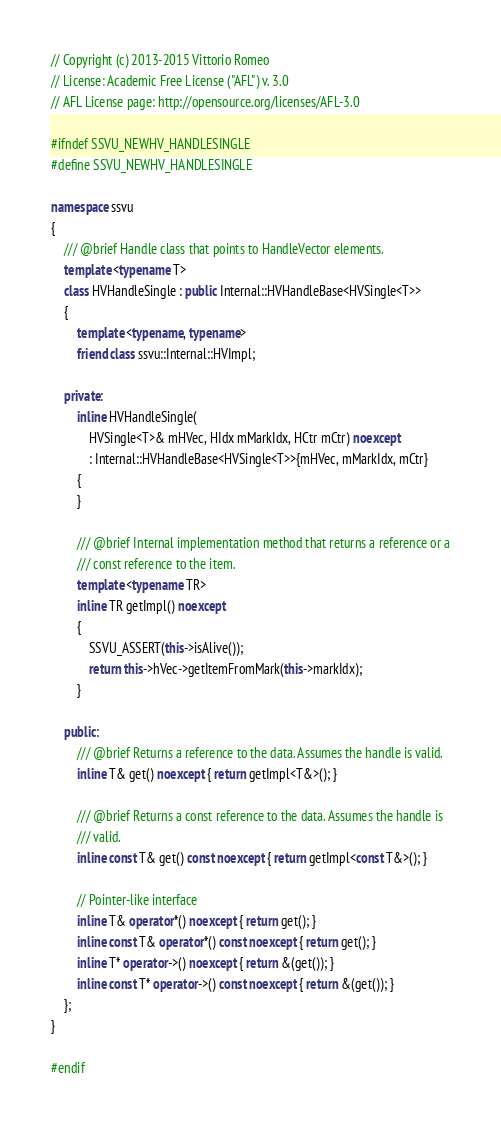Convert code to text. <code><loc_0><loc_0><loc_500><loc_500><_C++_>// Copyright (c) 2013-2015 Vittorio Romeo
// License: Academic Free License ("AFL") v. 3.0
// AFL License page: http://opensource.org/licenses/AFL-3.0

#ifndef SSVU_NEWHV_HANDLESINGLE
#define SSVU_NEWHV_HANDLESINGLE

namespace ssvu
{
    /// @brief Handle class that points to HandleVector elements.
    template <typename T>
    class HVHandleSingle : public Internal::HVHandleBase<HVSingle<T>>
    {
        template <typename, typename>
        friend class ssvu::Internal::HVImpl;

    private:
        inline HVHandleSingle(
            HVSingle<T>& mHVec, HIdx mMarkIdx, HCtr mCtr) noexcept
            : Internal::HVHandleBase<HVSingle<T>>{mHVec, mMarkIdx, mCtr}
        {
        }

        /// @brief Internal implementation method that returns a reference or a
        /// const reference to the item.
        template <typename TR>
        inline TR getImpl() noexcept
        {
            SSVU_ASSERT(this->isAlive());
            return this->hVec->getItemFromMark(this->markIdx);
        }

    public:
        /// @brief Returns a reference to the data. Assumes the handle is valid.
        inline T& get() noexcept { return getImpl<T&>(); }

        /// @brief Returns a const reference to the data. Assumes the handle is
        /// valid.
        inline const T& get() const noexcept { return getImpl<const T&>(); }

        // Pointer-like interface
        inline T& operator*() noexcept { return get(); }
        inline const T& operator*() const noexcept { return get(); }
        inline T* operator->() noexcept { return &(get()); }
        inline const T* operator->() const noexcept { return &(get()); }
    };
}

#endif</code> 